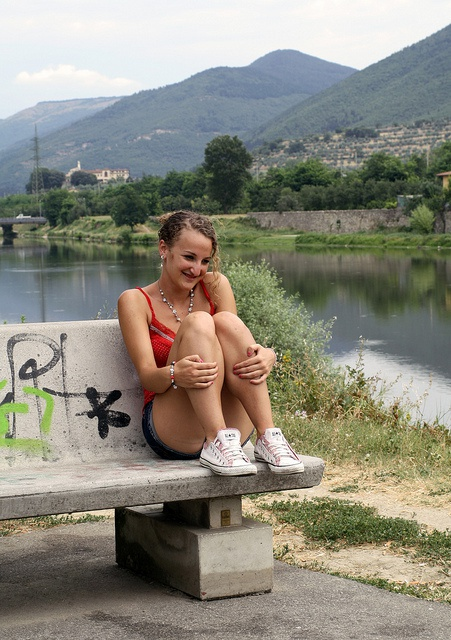Describe the objects in this image and their specific colors. I can see bench in white, darkgray, black, gray, and lightgray tones, people in white, brown, maroon, and tan tones, and car in white, darkgray, gray, and lightgray tones in this image. 